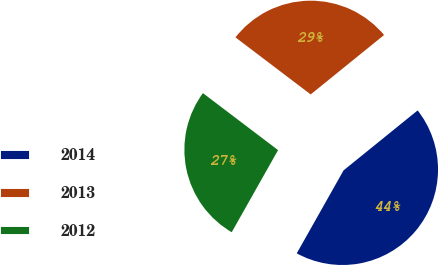Convert chart. <chart><loc_0><loc_0><loc_500><loc_500><pie_chart><fcel>2014<fcel>2013<fcel>2012<nl><fcel>44.01%<fcel>28.84%<fcel>27.15%<nl></chart> 